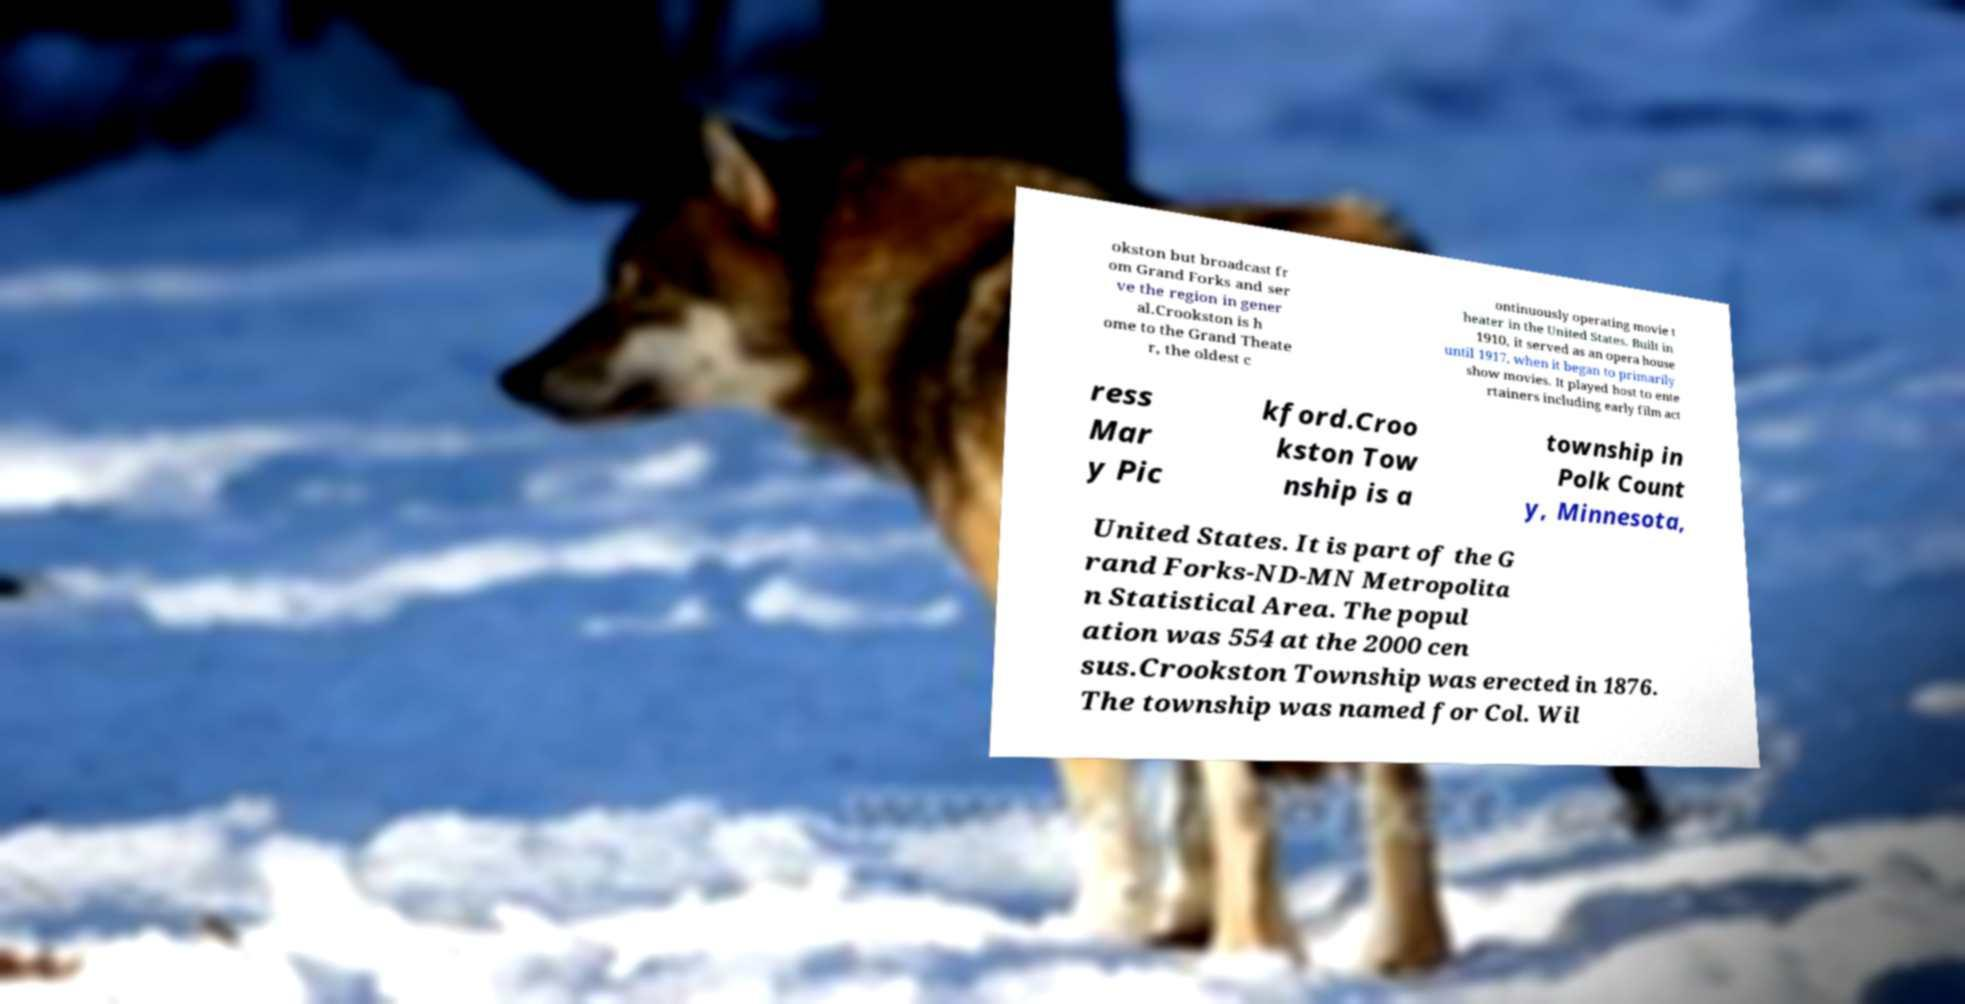Can you read and provide the text displayed in the image?This photo seems to have some interesting text. Can you extract and type it out for me? okston but broadcast fr om Grand Forks and ser ve the region in gener al.Crookston is h ome to the Grand Theate r, the oldest c ontinuously operating movie t heater in the United States. Built in 1910, it served as an opera house until 1917, when it began to primarily show movies. It played host to ente rtainers including early film act ress Mar y Pic kford.Croo kston Tow nship is a township in Polk Count y, Minnesota, United States. It is part of the G rand Forks-ND-MN Metropolita n Statistical Area. The popul ation was 554 at the 2000 cen sus.Crookston Township was erected in 1876. The township was named for Col. Wil 